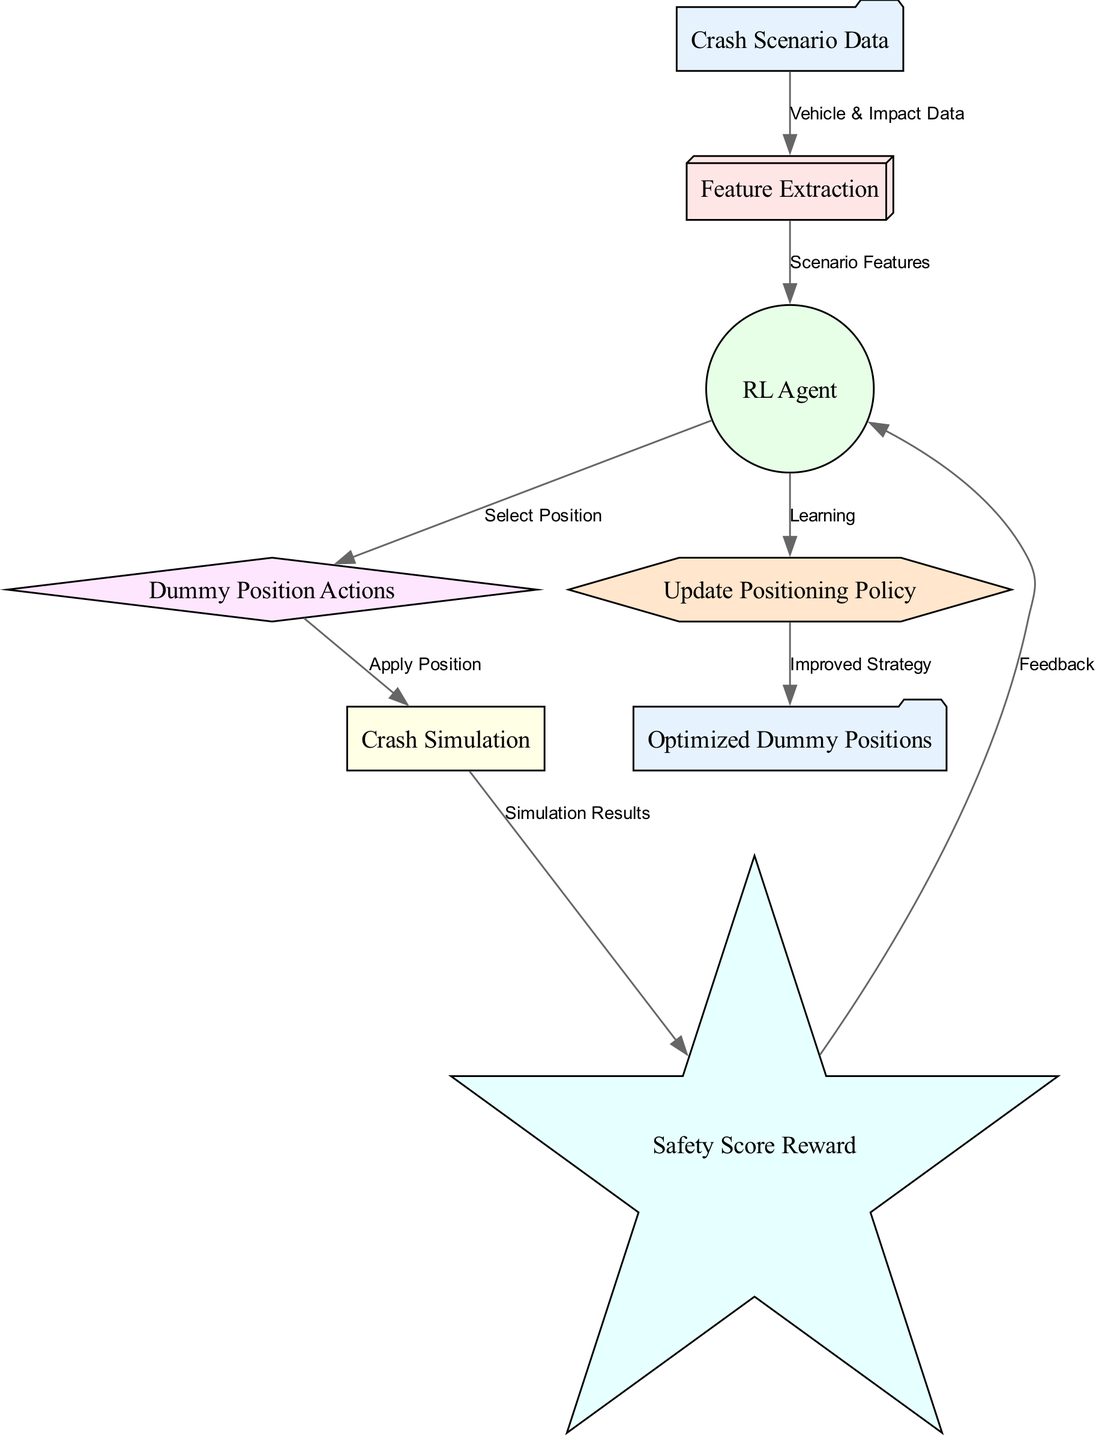What is the starting point of the process? The diagram begins with the "Crash Scenario Data" node, indicating this is the initial input of the process.
Answer: Crash Scenario Data How many nodes are present in the diagram? There are a total of eight nodes in the diagram, representing different stages in the reinforcement learning process.
Answer: 8 What type of node is "RL Agent"? The "RL Agent" node is represented as a circle in the diagram, indicating its specific role in the process.
Answer: Circle Which node follows "Reward"? After "Reward," the flow indicates that it goes back to "RL Agent," suggesting feedback is utilized for learning.
Answer: RL Agent What action follows the "Simulation" node? The "Simulation" node leads to the "Reward" node, showing that results from the simulation are evaluated next.
Answer: Reward Which two nodes are connected by the label "Safety Score Reward"? The "Reward" node and the "Simulation" node are connected with the label "Safety Score Reward," illustrating the feedback mechanism.
Answer: Reward and Simulation How does the RL Agent receive feedback? The "RL Agent" receives feedback from the "Reward" node, which keeps the learning process iterative.
Answer: From Reward What comes after "Update Positioning Policy"? The process then moves to the "Optimized Dummy Positions," signifying that improved strategies are outputted at this stage.
Answer: Optimized Dummy Positions What is the relationship between "Feature Extraction" and "RL Agent"? The "Feature Extraction" node provides "Scenario Features" to the "RL Agent," indicating that the extracted features are essential for the agent's functioning.
Answer: Scenario Features 